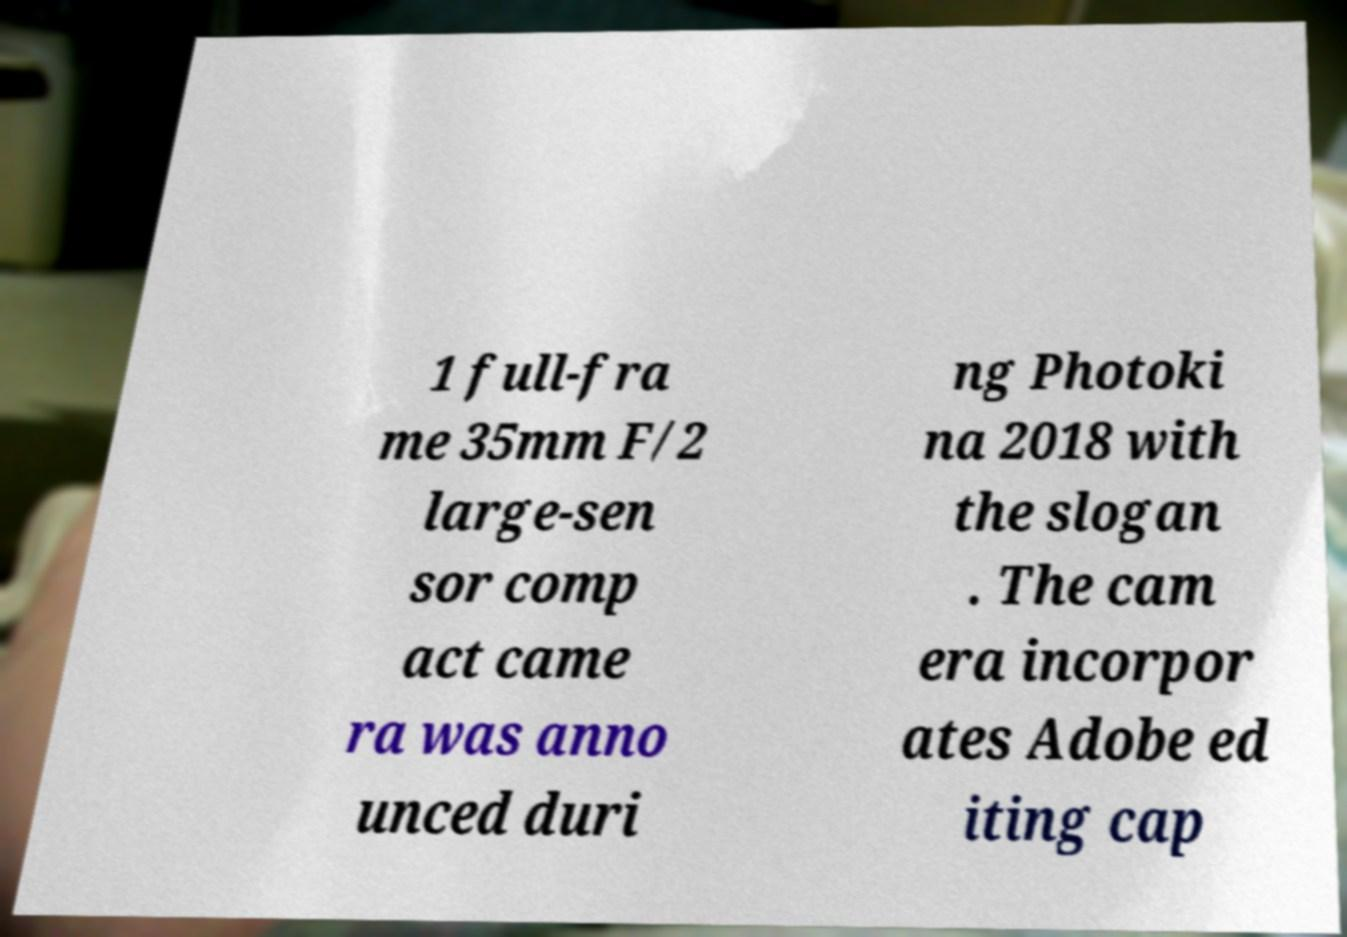What messages or text are displayed in this image? I need them in a readable, typed format. 1 full-fra me 35mm F/2 large-sen sor comp act came ra was anno unced duri ng Photoki na 2018 with the slogan . The cam era incorpor ates Adobe ed iting cap 